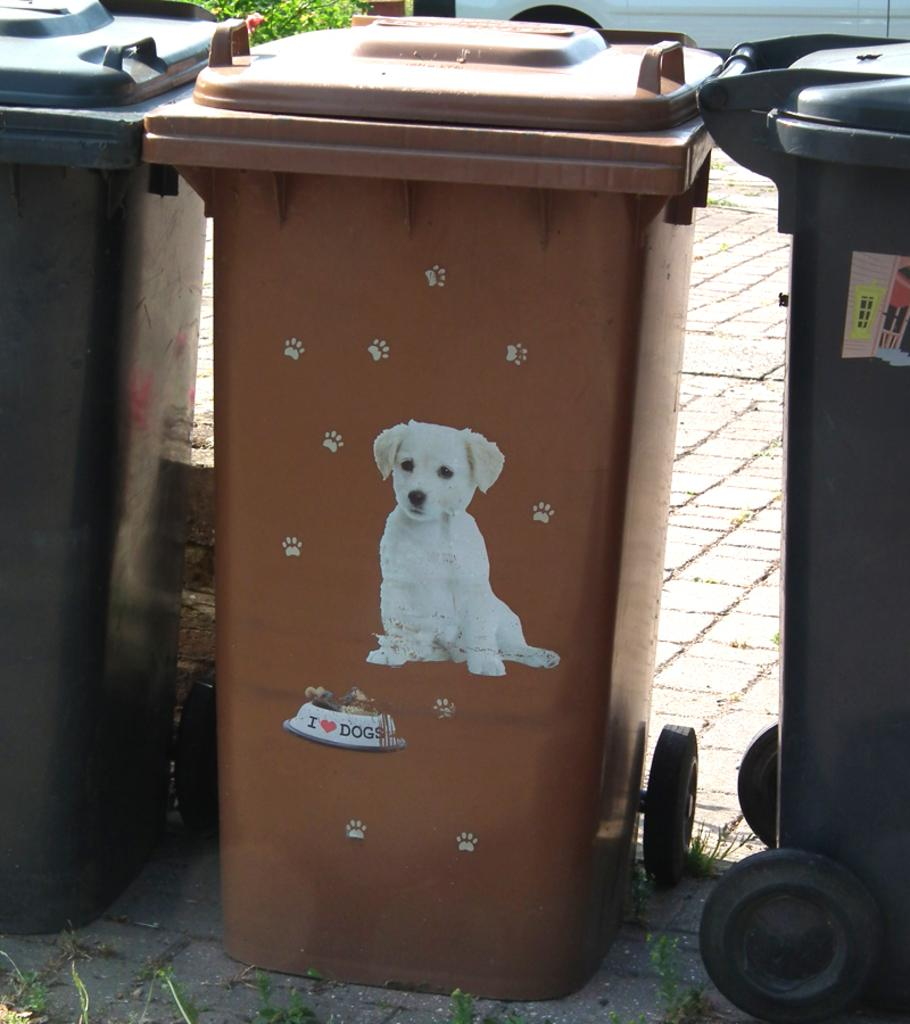<image>
Share a concise interpretation of the image provided. Brown garbage can with a picture of a dog and the words "I Love Dogs" on the bottom. 